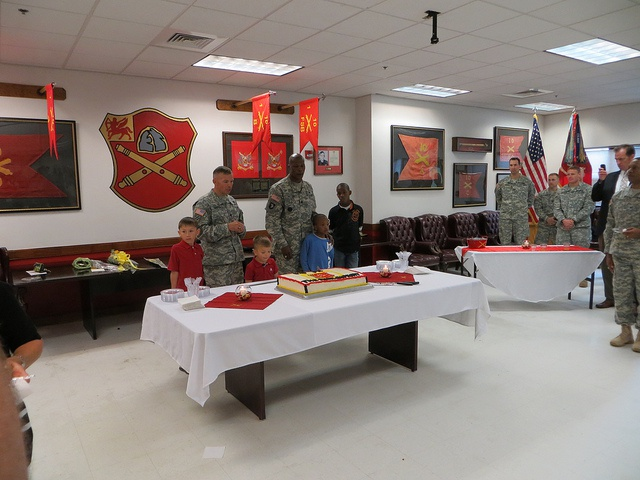Describe the objects in this image and their specific colors. I can see dining table in gray, darkgray, lightgray, black, and brown tones, dining table in gray, darkgray, salmon, and lightgray tones, people in gray, black, and maroon tones, people in gray, black, and maroon tones, and people in gray and black tones in this image. 